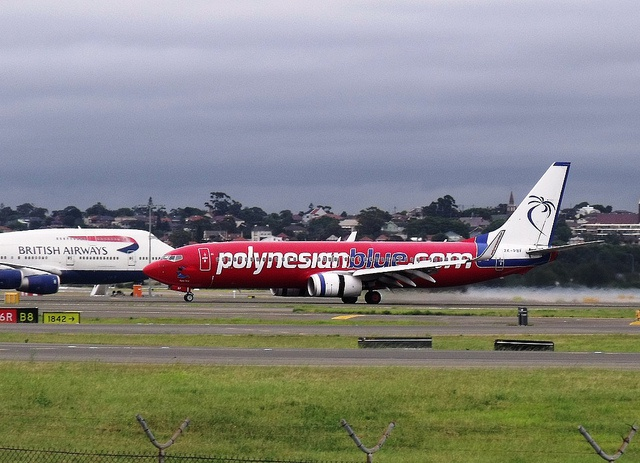Describe the objects in this image and their specific colors. I can see airplane in lavender, white, black, maroon, and brown tones and airplane in lavender, lightgray, black, darkgray, and gray tones in this image. 